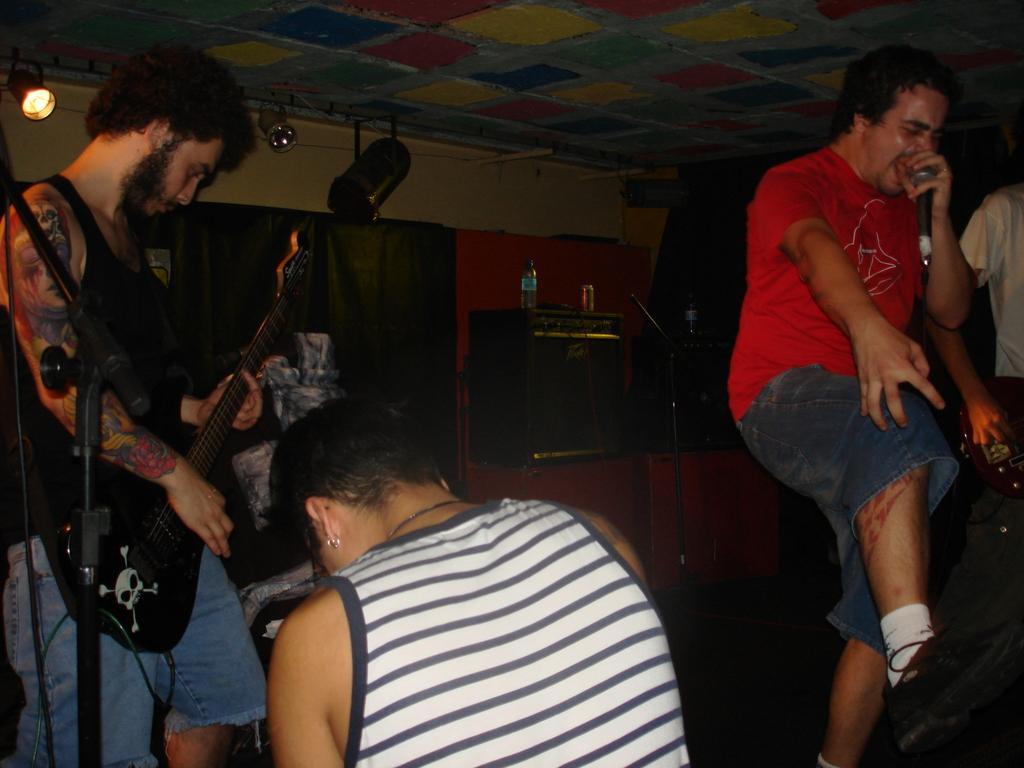How would you summarize this image in a sentence or two? In this Image I see 4 persons in which this man is holding the mic, this man is holding the guitar and this person is holding a musical instrument. In the background I see the wall, 2 bottles and a can and I see the light over here. 